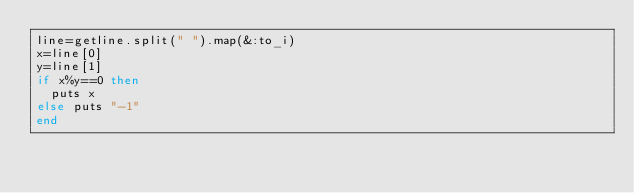<code> <loc_0><loc_0><loc_500><loc_500><_Ruby_>line=getline.split(" ").map(&:to_i)
x=line[0]
y=line[1]
if x%y==0 then
  puts x
else puts "-1"
end
</code> 